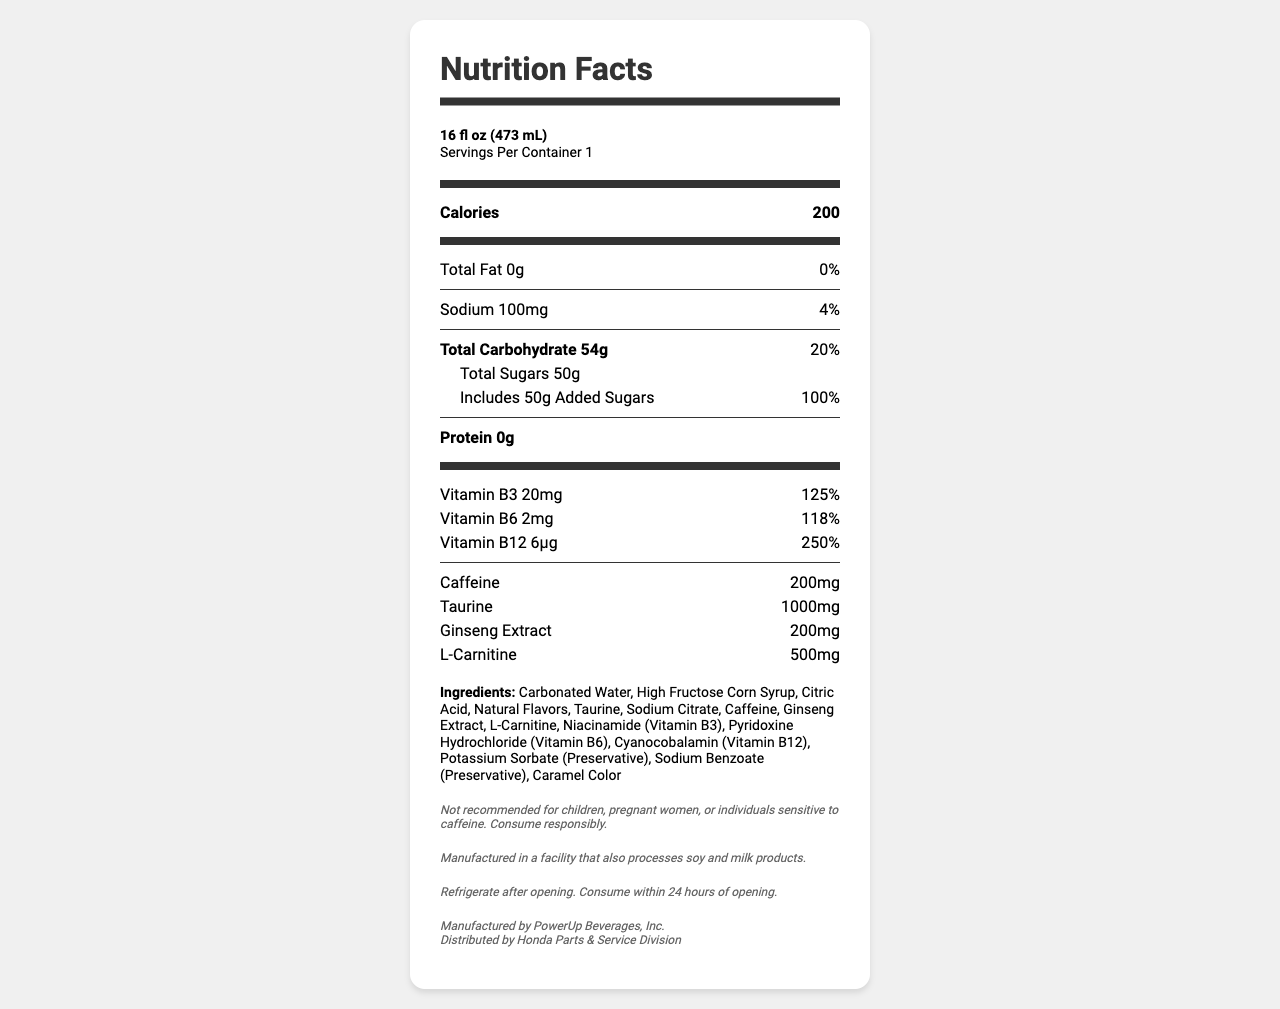what is the serving size? The serving size is explicitly mentioned at the top of the label as 16 fl oz (473 mL).
Answer: 16 fl oz (473 mL) how many calories are there per serving? The calories per serving are 200, clearly stated in the Calories section.
Answer: 200 how many grams of sugar are there in a serving? The sugars section shows a total of 50g.
Answer: 50g what are the storage instructions for this product? The storage instructions are mentioned near the bottom of the document.
Answer: Refrigerate after opening. Consume within 24 hours of opening. how much caffeine is in the drink? The amount of caffeine can be found in the list near the bottom of the document. It is 200mg.
Answer: 200mg how much sodium is present in one serving? A. 50mg B. 100mg C. 200mg D. 150mg According to the sodium section of the label, there is 100mg of sodium present in one serving.
Answer: B which vitamin has the highest daily value percentage? A. Vitamin B3 B. Vitamin B6 C. Vitamin B12 D. Vitamin C Vitamin B12 has a daily value of 250%, which is the highest among the listed vitamins.
Answer: C is this drink suitable for children? The disclaimer states that the product is not recommended for children.
Answer: No summarize the main components and warning information mentioned on this label. The label provides detailed information about the drink's nutritional content, including its high sugar content and energy-related ingredients, along with important warnings about its consumption.
Answer: TurboCharge Mechanic's Blend is an energy drink with 200 calories, no fat or protein, 54g of carbohydrates, and 50g of sugar. It contains significant amounts of vitamins B3, B6, and B12, caffeine, taurine, ginseng extract, and L-carnitine. The label includes a note about allergens, storage instructions, and a disclaimer about its suitability for certain individuals. what is the amount of taurine in the drink? The amount of taurine is listed as 1000mg in the ingredients section.
Answer: 1000mg what is the manufacturer of this beverage? The manufacturer information is located near the bottom and specifies PowerUp Beverages, Inc.
Answer: PowerUp Beverages, Inc. can we determine the price of the drink from this document? The document does not contain any information regarding the price of the drink.
Answer: Cannot be determined 